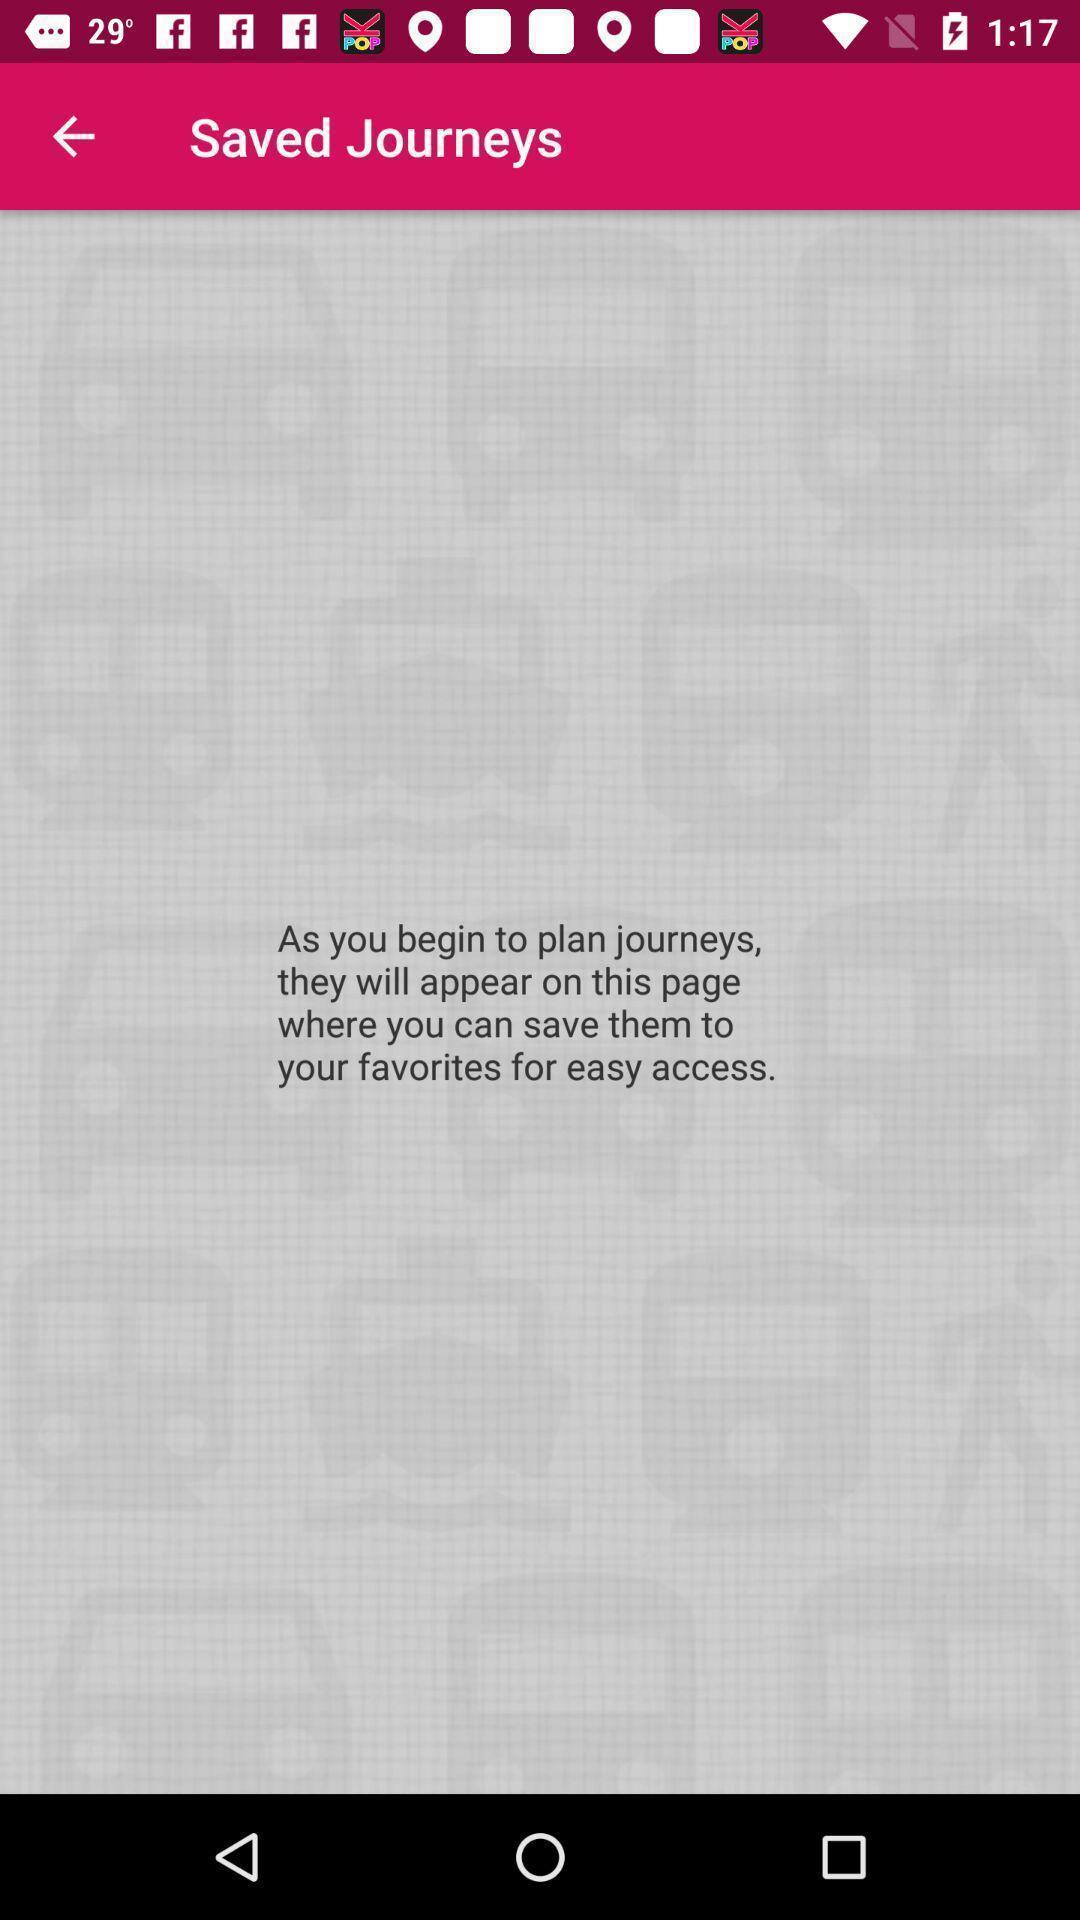Summarize the main components in this picture. Screen displaying the saved journeys page. 